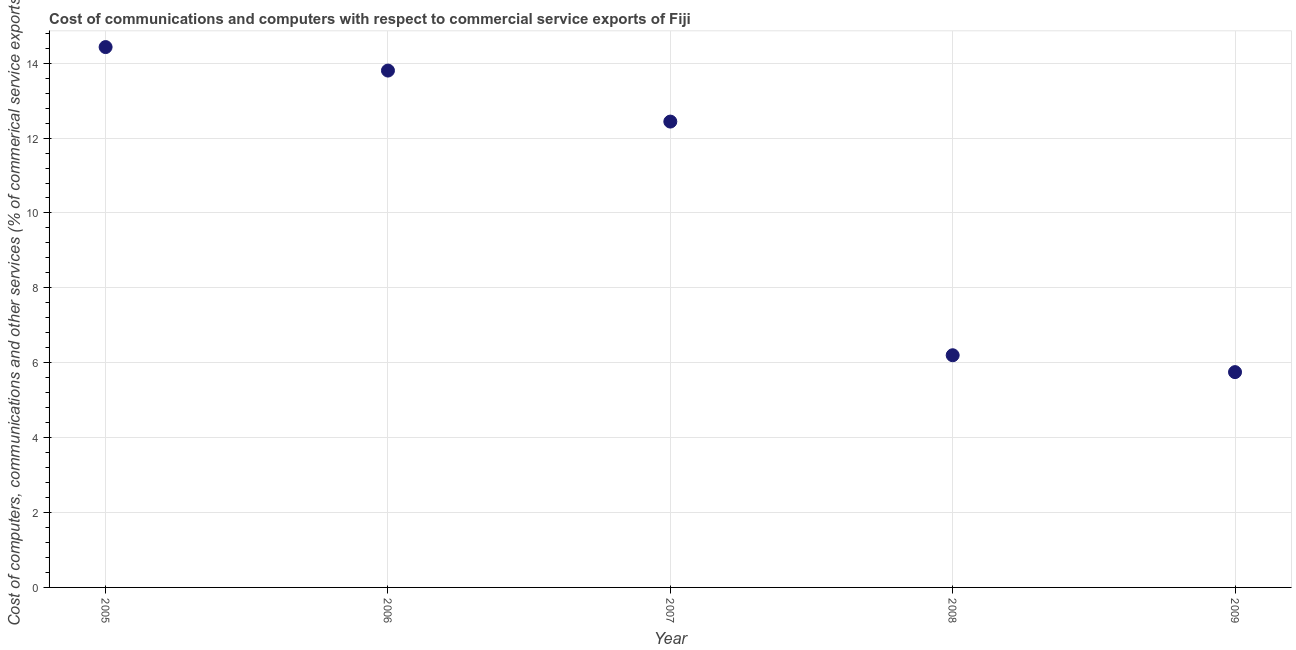What is the cost of communications in 2007?
Offer a very short reply. 12.44. Across all years, what is the maximum  computer and other services?
Your response must be concise. 14.43. Across all years, what is the minimum  computer and other services?
Provide a short and direct response. 5.75. In which year was the  computer and other services maximum?
Your answer should be compact. 2005. In which year was the  computer and other services minimum?
Offer a very short reply. 2009. What is the sum of the cost of communications?
Offer a very short reply. 52.62. What is the difference between the cost of communications in 2005 and 2009?
Make the answer very short. 8.68. What is the average  computer and other services per year?
Your response must be concise. 10.52. What is the median cost of communications?
Your response must be concise. 12.44. What is the ratio of the  computer and other services in 2005 to that in 2007?
Offer a very short reply. 1.16. What is the difference between the highest and the second highest  computer and other services?
Your response must be concise. 0.63. Is the sum of the cost of communications in 2006 and 2007 greater than the maximum cost of communications across all years?
Provide a short and direct response. Yes. What is the difference between the highest and the lowest  computer and other services?
Offer a terse response. 8.68. Does the  computer and other services monotonically increase over the years?
Keep it short and to the point. No. How many dotlines are there?
Offer a terse response. 1. How many years are there in the graph?
Provide a short and direct response. 5. What is the difference between two consecutive major ticks on the Y-axis?
Your response must be concise. 2. Are the values on the major ticks of Y-axis written in scientific E-notation?
Provide a short and direct response. No. Does the graph contain any zero values?
Provide a short and direct response. No. What is the title of the graph?
Give a very brief answer. Cost of communications and computers with respect to commercial service exports of Fiji. What is the label or title of the X-axis?
Make the answer very short. Year. What is the label or title of the Y-axis?
Offer a terse response. Cost of computers, communications and other services (% of commerical service exports). What is the Cost of computers, communications and other services (% of commerical service exports) in 2005?
Your answer should be very brief. 14.43. What is the Cost of computers, communications and other services (% of commerical service exports) in 2006?
Offer a terse response. 13.8. What is the Cost of computers, communications and other services (% of commerical service exports) in 2007?
Provide a short and direct response. 12.44. What is the Cost of computers, communications and other services (% of commerical service exports) in 2008?
Make the answer very short. 6.2. What is the Cost of computers, communications and other services (% of commerical service exports) in 2009?
Your answer should be compact. 5.75. What is the difference between the Cost of computers, communications and other services (% of commerical service exports) in 2005 and 2006?
Provide a short and direct response. 0.63. What is the difference between the Cost of computers, communications and other services (% of commerical service exports) in 2005 and 2007?
Ensure brevity in your answer.  1.99. What is the difference between the Cost of computers, communications and other services (% of commerical service exports) in 2005 and 2008?
Ensure brevity in your answer.  8.23. What is the difference between the Cost of computers, communications and other services (% of commerical service exports) in 2005 and 2009?
Provide a succinct answer. 8.68. What is the difference between the Cost of computers, communications and other services (% of commerical service exports) in 2006 and 2007?
Provide a succinct answer. 1.36. What is the difference between the Cost of computers, communications and other services (% of commerical service exports) in 2006 and 2008?
Keep it short and to the point. 7.6. What is the difference between the Cost of computers, communications and other services (% of commerical service exports) in 2006 and 2009?
Make the answer very short. 8.05. What is the difference between the Cost of computers, communications and other services (% of commerical service exports) in 2007 and 2008?
Your answer should be compact. 6.24. What is the difference between the Cost of computers, communications and other services (% of commerical service exports) in 2007 and 2009?
Offer a terse response. 6.69. What is the difference between the Cost of computers, communications and other services (% of commerical service exports) in 2008 and 2009?
Your response must be concise. 0.45. What is the ratio of the Cost of computers, communications and other services (% of commerical service exports) in 2005 to that in 2006?
Your response must be concise. 1.04. What is the ratio of the Cost of computers, communications and other services (% of commerical service exports) in 2005 to that in 2007?
Keep it short and to the point. 1.16. What is the ratio of the Cost of computers, communications and other services (% of commerical service exports) in 2005 to that in 2008?
Your answer should be very brief. 2.33. What is the ratio of the Cost of computers, communications and other services (% of commerical service exports) in 2005 to that in 2009?
Your answer should be compact. 2.51. What is the ratio of the Cost of computers, communications and other services (% of commerical service exports) in 2006 to that in 2007?
Your response must be concise. 1.11. What is the ratio of the Cost of computers, communications and other services (% of commerical service exports) in 2006 to that in 2008?
Your answer should be very brief. 2.23. What is the ratio of the Cost of computers, communications and other services (% of commerical service exports) in 2006 to that in 2009?
Offer a terse response. 2.4. What is the ratio of the Cost of computers, communications and other services (% of commerical service exports) in 2007 to that in 2008?
Your answer should be compact. 2.01. What is the ratio of the Cost of computers, communications and other services (% of commerical service exports) in 2007 to that in 2009?
Offer a very short reply. 2.16. What is the ratio of the Cost of computers, communications and other services (% of commerical service exports) in 2008 to that in 2009?
Make the answer very short. 1.08. 